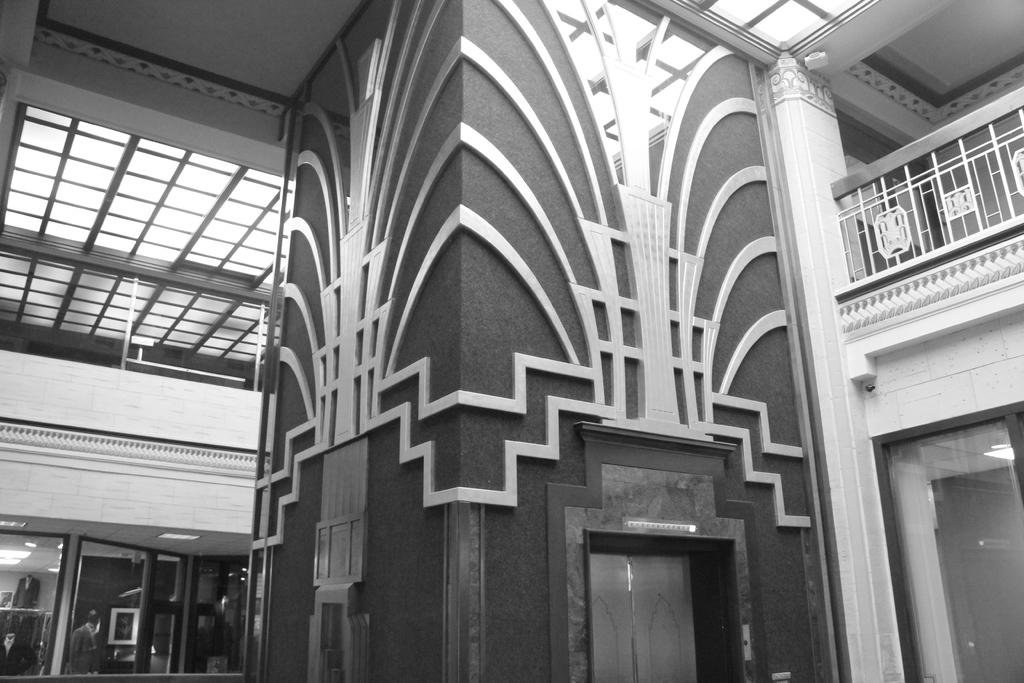What is the color scheme of the image? The image is black and white. What type of location is depicted in the image? The image shows an interior view of a building. Are there any light sources visible in the image? Yes, there are lights visible in the image. What is one architectural feature that can be seen in the image? There is a door in the image. What type of glass objects or features can be seen in the image? There are glasses (possibly windows or glass objects) in the image. How many friends are attempting to enjoy the summer in the image? There are no friends or any indication of summer in the image; it is an interior view of a building with a black and white color scheme. 